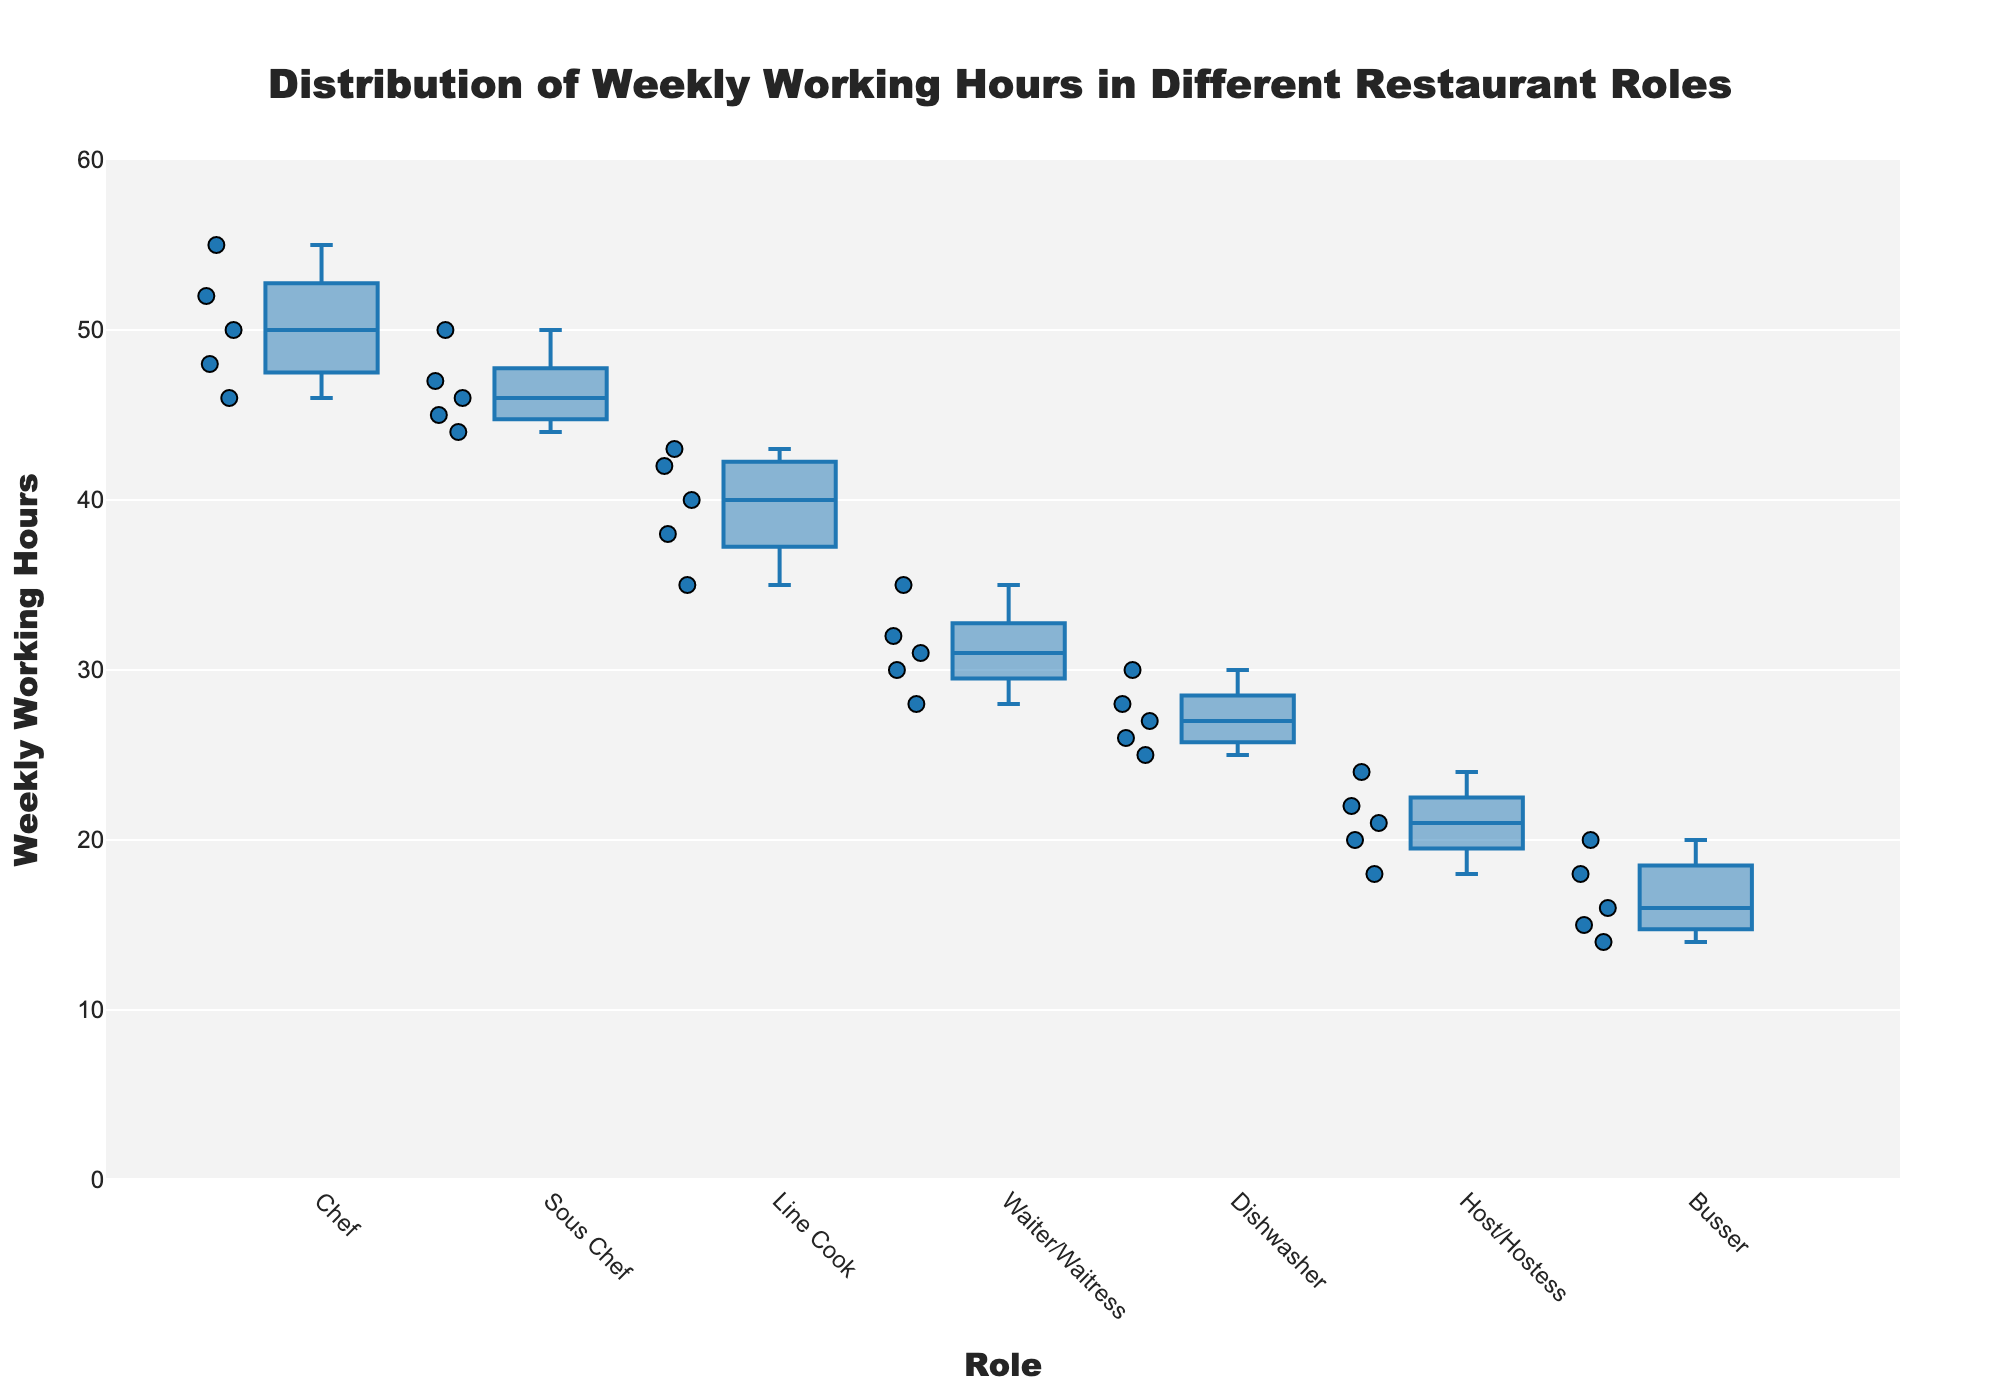What is the title of the box plot? The title is written at the top center of the plot and is usually larger and bolder than other texts.
Answer: Distribution of Weekly Working Hours in Different Restaurant Roles What is the y-axis title? The title of the y-axis is found on the left side of the plot. It describes what the y-axis measures.
Answer: Weekly Working Hours What is the range of Weekly Working Hours depicted on the y-axis? Inspect the y-axis labels to determine the minimum and maximum values shown.
Answer: 0 to 60 Which role shows the highest median weekly working hours? The median is represented by the line inside the box. Compare the medians across different roles.
Answer: Chef Which role has the smallest interquartile range (IQR) for weekly working hours? The IQR is the range between the first quartile (bottom of the box) and the third quartile (top of the box). Compare the sizes of the boxes across roles.
Answer: Line Cook Which role has the widest spread of weekly working hours? The spread is determined by the distance between the smallest and largest data points, which may include outliers.
Answer: Chef How do the working hours of waiters/waitresses compare to those of line cooks? Compare the medians and the overall spread of the boxes for both roles.
Answer: Line Cooks have higher working hours than Waiters/Waitresses on average Are there any outliers in the Host/Hostess role? Outliers are represented by individual points outside the whiskers' range. Check if there are any such points for the Host/Hostess role.
Answer: No What is the average weekly working hours for dishwashers and how does it compare to busser's working hours? Calculate the average for dishwasher hours. Compare this average to that of bussers visually.
Answer: Dishwashers’ average is around 27 hours, whereas Bussers average around 17 hours Which role has the lowest minimum weekly working hours? Identify the lowest point in the box plots for each role and compare them.
Answer: Busser 